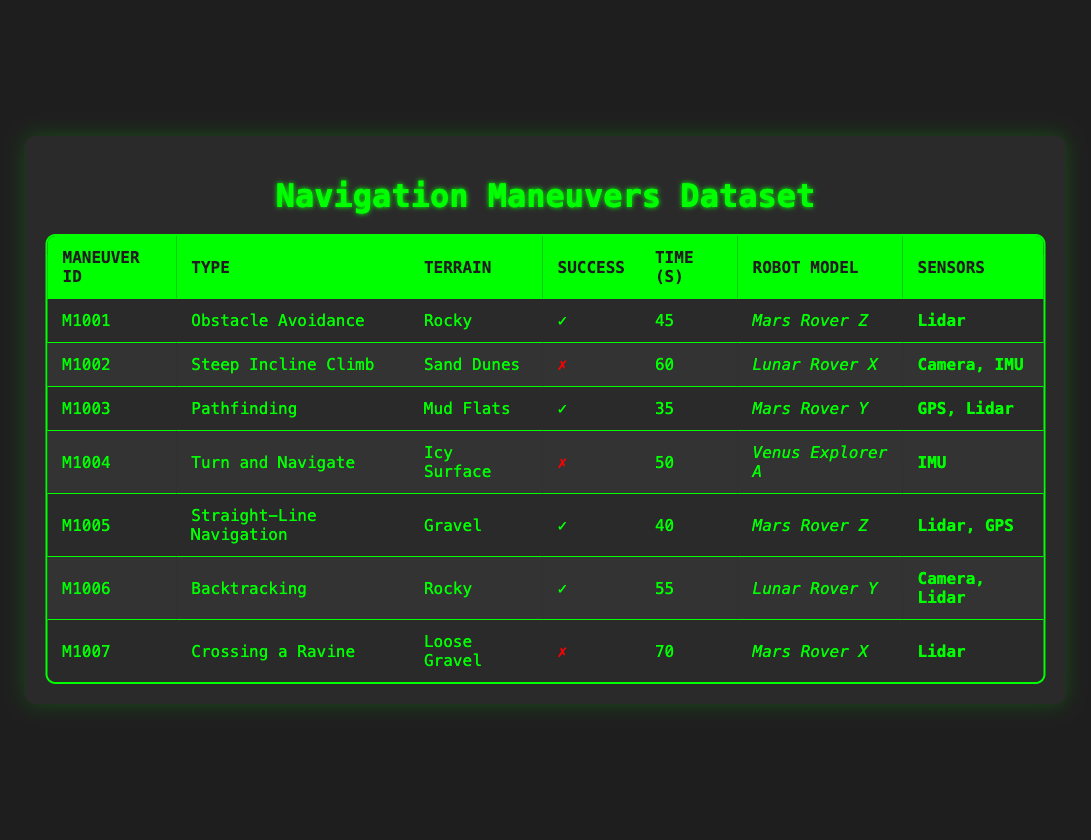What is the success rate of the navigation maneuvers? From the table, there are 7 navigation maneuvers listed. Out of these, 4 are marked as successful (✓). To calculate the success rate, divide the number of successful maneuvers by the total number of maneuvers: 4 / 7 = approximately 0.57. The success rate is then expressed as a percentage: 0.57 * 100 = 57%.
Answer: 57% Which robot model had the highest execution time for a failed maneuver? The table lists the execution times for each failed maneuver. The failed maneuvers are for the Lunar Rover X (60 seconds), Venus Explorer A (50 seconds), and Mars Rover X (70 seconds). The highest execution time among these is 70 seconds for the maneuver "Crossing a Ravine" using the Mars Rover X.
Answer: 70 seconds How many different types of maneuvers were successful? The successful maneuvers, indicated with a check (✓), are "Obstacle Avoidance," "Pathfinding," "Straight-Line Navigation," and "Backtracking." Counting these unique types gives us a total of 4 different successful maneuvers.
Answer: 4 Was "Steep Incline Climb" successful? The maneuver "Steep Incline Climb," performed by the Lunar Rover X, is marked as a failure (✗) in the table. Therefore, it was not successful.
Answer: No What is the average execution time of the successful maneuvers? First, identify the execution times of the successful maneuvers: 45 seconds (Obstacle Avoidance), 35 seconds (Pathfinding), 40 seconds (Straight-Line Navigation), and 55 seconds (Backtracking). Sum these values: 45 + 35 + 40 + 55 = 175 seconds. There are 4 successful maneuvers, so the average is calculated by dividing the total time by the number of successful maneuvers: 175 / 4 = 43.75 seconds.
Answer: 43.75 seconds How many maneuvers were conducted on a rocky terrain? Looking through the table, there are two maneuvers conducted on rocky terrain: "Obstacle Avoidance" (successful) and "Backtracking" (successful). Therefore, there are a total of 2 maneuvers on rocky terrain.
Answer: 2 What is the success status of the "Turn and Navigate" maneuver? The "Turn and Navigate" maneuver, which was conducted on an icy surface by the Venus Explorer A, is marked as a failure (✗) in the table. Thus, its success status is false.
Answer: No Which sensor was used in the most successful maneuvers? The successful maneuvers listed include "Obstacle Avoidance" using Lidar, "Pathfinding" using GPS and Lidar, "Straight-Line Navigation" using Lidar and GPS, and "Backtracking" using Camera and Lidar. Lidar appears in 3 out of the 4 successful maneuvers, making it the most frequently used sensor in successful maneuvers.
Answer: Lidar 